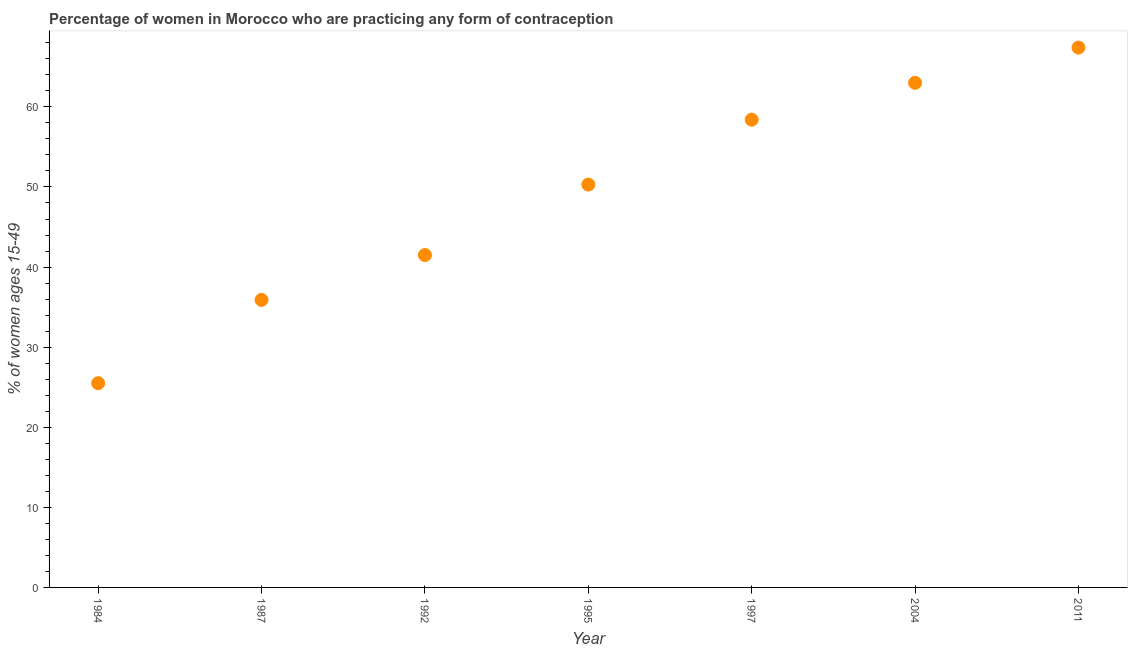What is the contraceptive prevalence in 1997?
Offer a very short reply. 58.4. Across all years, what is the maximum contraceptive prevalence?
Give a very brief answer. 67.4. What is the sum of the contraceptive prevalence?
Your response must be concise. 342. What is the difference between the contraceptive prevalence in 1984 and 2004?
Provide a succinct answer. -37.5. What is the average contraceptive prevalence per year?
Provide a succinct answer. 48.86. What is the median contraceptive prevalence?
Your answer should be very brief. 50.3. Do a majority of the years between 1997 and 1987 (inclusive) have contraceptive prevalence greater than 4 %?
Provide a short and direct response. Yes. What is the ratio of the contraceptive prevalence in 1992 to that in 2011?
Your answer should be very brief. 0.62. Is the difference between the contraceptive prevalence in 1995 and 1997 greater than the difference between any two years?
Offer a very short reply. No. What is the difference between the highest and the second highest contraceptive prevalence?
Your answer should be compact. 4.4. Is the sum of the contraceptive prevalence in 1987 and 2004 greater than the maximum contraceptive prevalence across all years?
Make the answer very short. Yes. What is the difference between the highest and the lowest contraceptive prevalence?
Make the answer very short. 41.9. In how many years, is the contraceptive prevalence greater than the average contraceptive prevalence taken over all years?
Provide a succinct answer. 4. How many years are there in the graph?
Offer a very short reply. 7. What is the difference between two consecutive major ticks on the Y-axis?
Give a very brief answer. 10. Are the values on the major ticks of Y-axis written in scientific E-notation?
Provide a succinct answer. No. Does the graph contain grids?
Your response must be concise. No. What is the title of the graph?
Your answer should be compact. Percentage of women in Morocco who are practicing any form of contraception. What is the label or title of the Y-axis?
Ensure brevity in your answer.  % of women ages 15-49. What is the % of women ages 15-49 in 1984?
Your answer should be very brief. 25.5. What is the % of women ages 15-49 in 1987?
Ensure brevity in your answer.  35.9. What is the % of women ages 15-49 in 1992?
Keep it short and to the point. 41.5. What is the % of women ages 15-49 in 1995?
Keep it short and to the point. 50.3. What is the % of women ages 15-49 in 1997?
Provide a short and direct response. 58.4. What is the % of women ages 15-49 in 2011?
Your answer should be very brief. 67.4. What is the difference between the % of women ages 15-49 in 1984 and 1987?
Your answer should be very brief. -10.4. What is the difference between the % of women ages 15-49 in 1984 and 1992?
Provide a short and direct response. -16. What is the difference between the % of women ages 15-49 in 1984 and 1995?
Your answer should be very brief. -24.8. What is the difference between the % of women ages 15-49 in 1984 and 1997?
Make the answer very short. -32.9. What is the difference between the % of women ages 15-49 in 1984 and 2004?
Ensure brevity in your answer.  -37.5. What is the difference between the % of women ages 15-49 in 1984 and 2011?
Your answer should be very brief. -41.9. What is the difference between the % of women ages 15-49 in 1987 and 1995?
Ensure brevity in your answer.  -14.4. What is the difference between the % of women ages 15-49 in 1987 and 1997?
Provide a succinct answer. -22.5. What is the difference between the % of women ages 15-49 in 1987 and 2004?
Provide a succinct answer. -27.1. What is the difference between the % of women ages 15-49 in 1987 and 2011?
Offer a terse response. -31.5. What is the difference between the % of women ages 15-49 in 1992 and 1995?
Your answer should be very brief. -8.8. What is the difference between the % of women ages 15-49 in 1992 and 1997?
Offer a terse response. -16.9. What is the difference between the % of women ages 15-49 in 1992 and 2004?
Give a very brief answer. -21.5. What is the difference between the % of women ages 15-49 in 1992 and 2011?
Keep it short and to the point. -25.9. What is the difference between the % of women ages 15-49 in 1995 and 2004?
Provide a short and direct response. -12.7. What is the difference between the % of women ages 15-49 in 1995 and 2011?
Your response must be concise. -17.1. What is the difference between the % of women ages 15-49 in 1997 and 2004?
Your response must be concise. -4.6. What is the difference between the % of women ages 15-49 in 1997 and 2011?
Keep it short and to the point. -9. What is the ratio of the % of women ages 15-49 in 1984 to that in 1987?
Offer a very short reply. 0.71. What is the ratio of the % of women ages 15-49 in 1984 to that in 1992?
Your answer should be very brief. 0.61. What is the ratio of the % of women ages 15-49 in 1984 to that in 1995?
Provide a succinct answer. 0.51. What is the ratio of the % of women ages 15-49 in 1984 to that in 1997?
Your response must be concise. 0.44. What is the ratio of the % of women ages 15-49 in 1984 to that in 2004?
Offer a very short reply. 0.41. What is the ratio of the % of women ages 15-49 in 1984 to that in 2011?
Keep it short and to the point. 0.38. What is the ratio of the % of women ages 15-49 in 1987 to that in 1992?
Offer a very short reply. 0.86. What is the ratio of the % of women ages 15-49 in 1987 to that in 1995?
Make the answer very short. 0.71. What is the ratio of the % of women ages 15-49 in 1987 to that in 1997?
Give a very brief answer. 0.61. What is the ratio of the % of women ages 15-49 in 1987 to that in 2004?
Make the answer very short. 0.57. What is the ratio of the % of women ages 15-49 in 1987 to that in 2011?
Your answer should be compact. 0.53. What is the ratio of the % of women ages 15-49 in 1992 to that in 1995?
Make the answer very short. 0.82. What is the ratio of the % of women ages 15-49 in 1992 to that in 1997?
Keep it short and to the point. 0.71. What is the ratio of the % of women ages 15-49 in 1992 to that in 2004?
Give a very brief answer. 0.66. What is the ratio of the % of women ages 15-49 in 1992 to that in 2011?
Make the answer very short. 0.62. What is the ratio of the % of women ages 15-49 in 1995 to that in 1997?
Your answer should be compact. 0.86. What is the ratio of the % of women ages 15-49 in 1995 to that in 2004?
Keep it short and to the point. 0.8. What is the ratio of the % of women ages 15-49 in 1995 to that in 2011?
Give a very brief answer. 0.75. What is the ratio of the % of women ages 15-49 in 1997 to that in 2004?
Offer a very short reply. 0.93. What is the ratio of the % of women ages 15-49 in 1997 to that in 2011?
Ensure brevity in your answer.  0.87. What is the ratio of the % of women ages 15-49 in 2004 to that in 2011?
Keep it short and to the point. 0.94. 